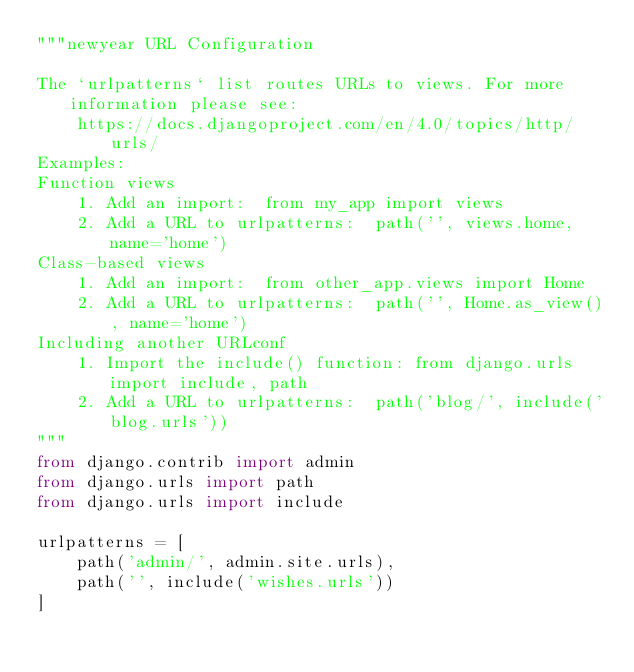Convert code to text. <code><loc_0><loc_0><loc_500><loc_500><_Python_>"""newyear URL Configuration

The `urlpatterns` list routes URLs to views. For more information please see:
    https://docs.djangoproject.com/en/4.0/topics/http/urls/
Examples:
Function views
    1. Add an import:  from my_app import views
    2. Add a URL to urlpatterns:  path('', views.home, name='home')
Class-based views
    1. Add an import:  from other_app.views import Home
    2. Add a URL to urlpatterns:  path('', Home.as_view(), name='home')
Including another URLconf
    1. Import the include() function: from django.urls import include, path
    2. Add a URL to urlpatterns:  path('blog/', include('blog.urls'))
"""
from django.contrib import admin
from django.urls import path
from django.urls import include

urlpatterns = [
    path('admin/', admin.site.urls),
    path('', include('wishes.urls'))
]
</code> 